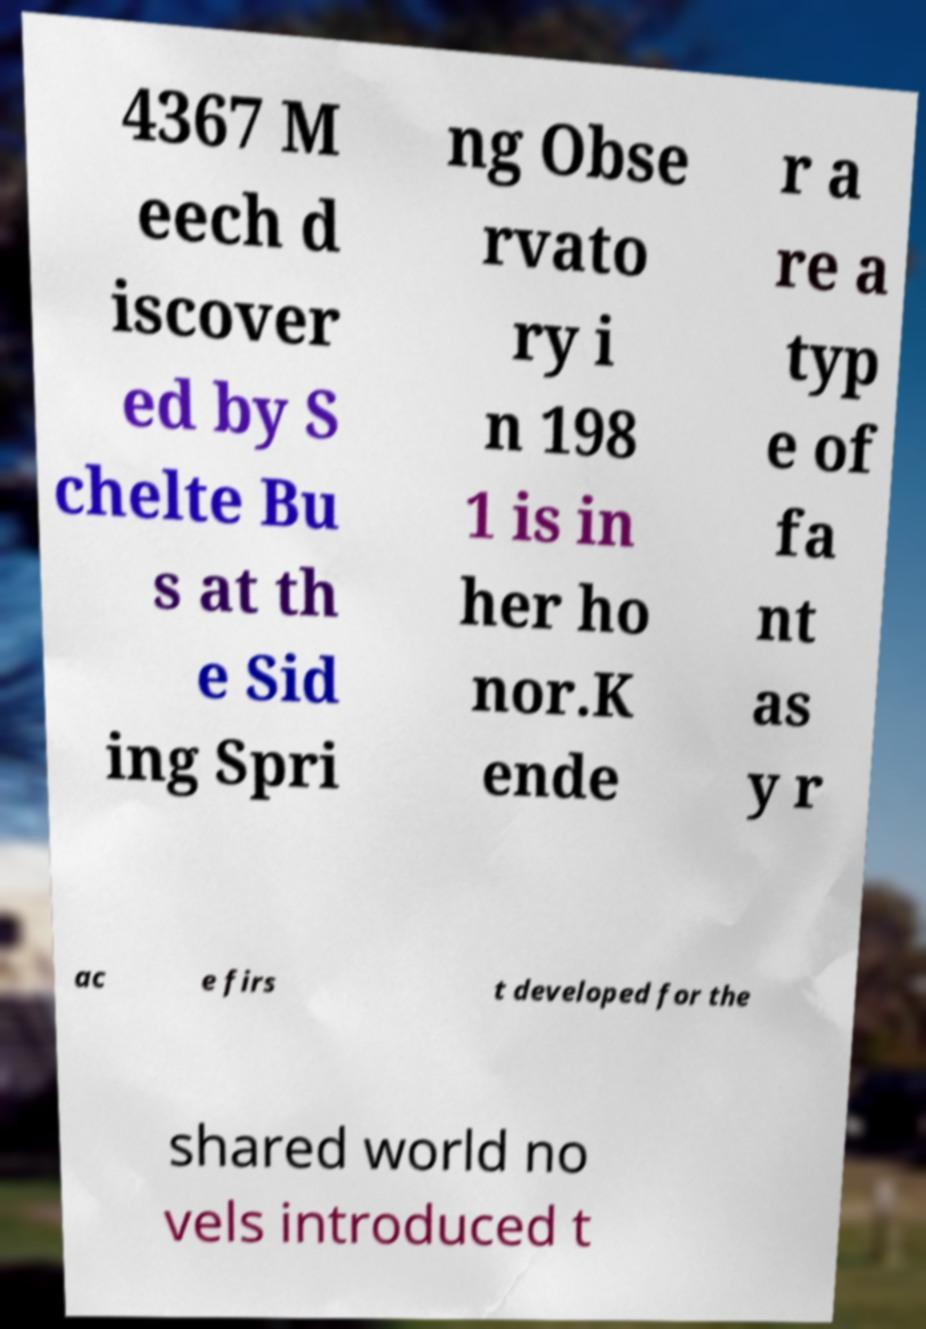Could you extract and type out the text from this image? 4367 M eech d iscover ed by S chelte Bu s at th e Sid ing Spri ng Obse rvato ry i n 198 1 is in her ho nor.K ende r a re a typ e of fa nt as y r ac e firs t developed for the shared world no vels introduced t 